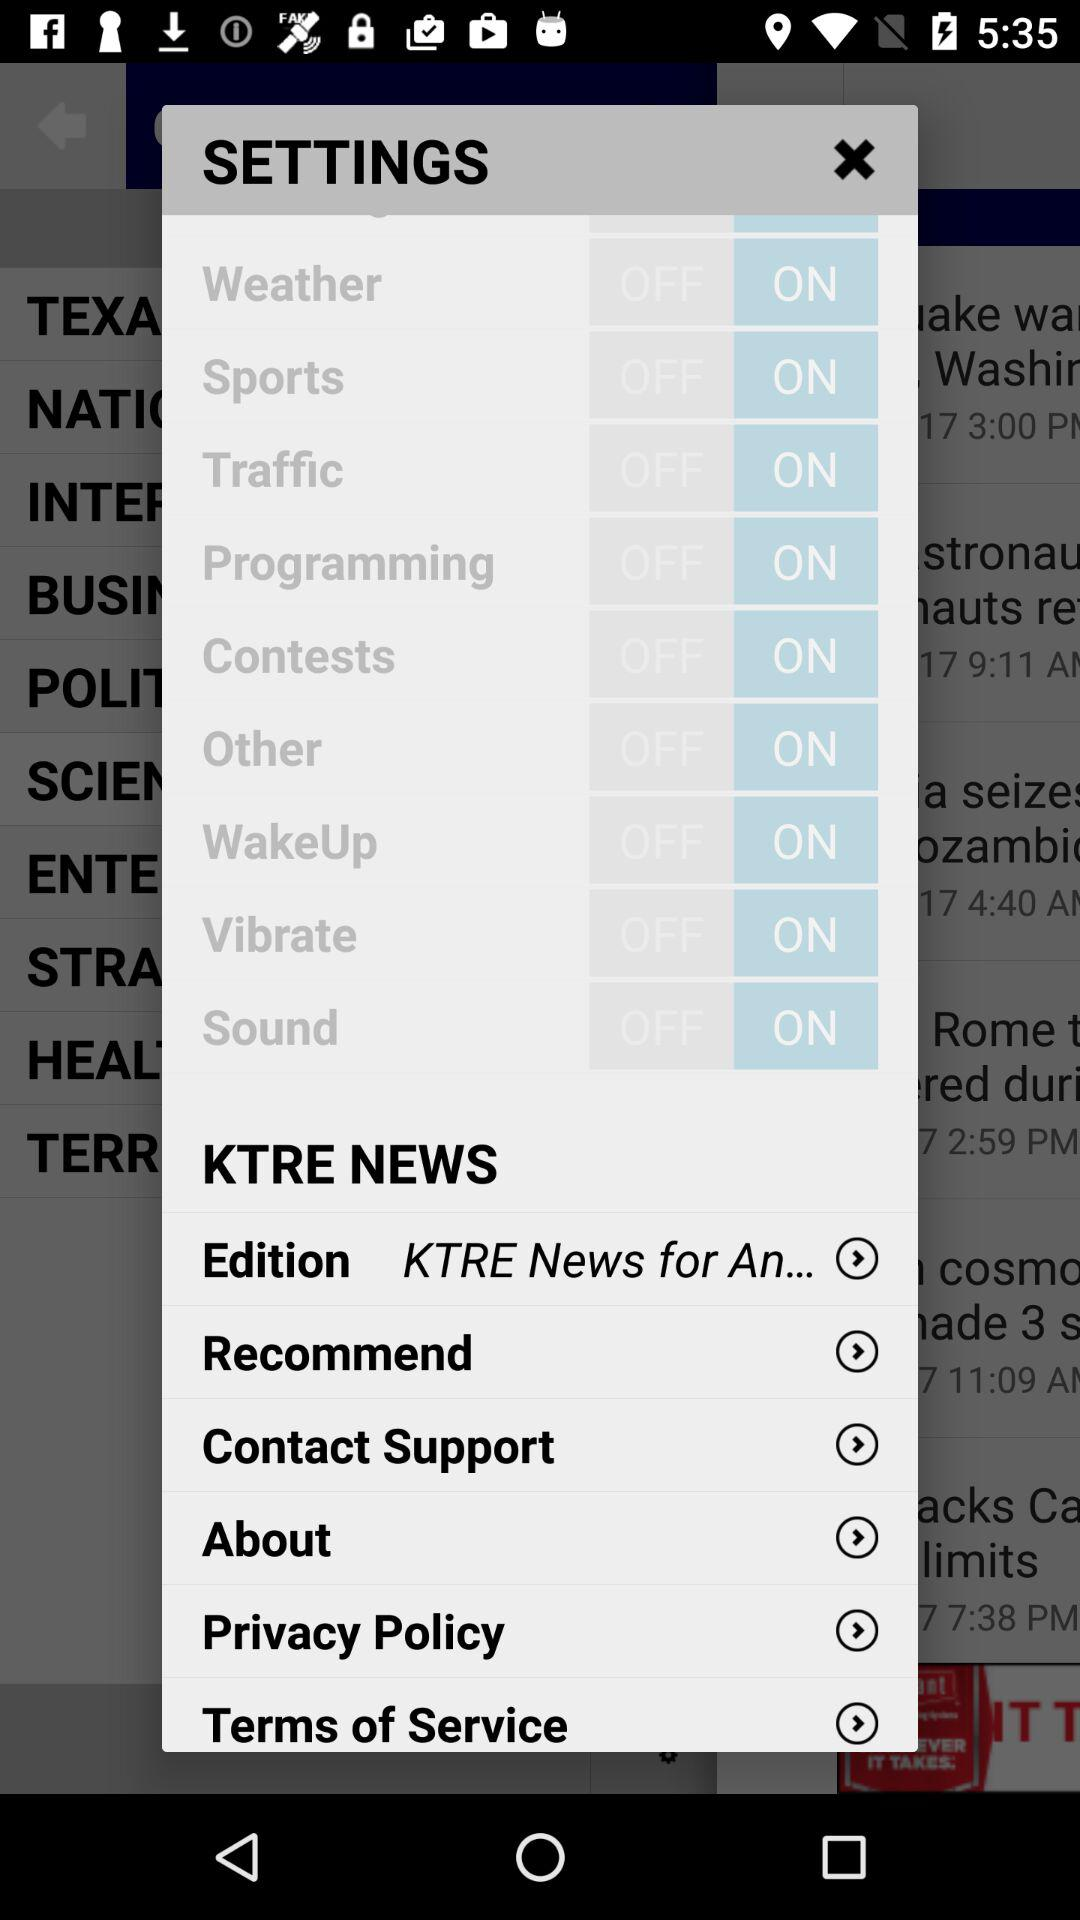What is the setting for weather? The setting is "on". 